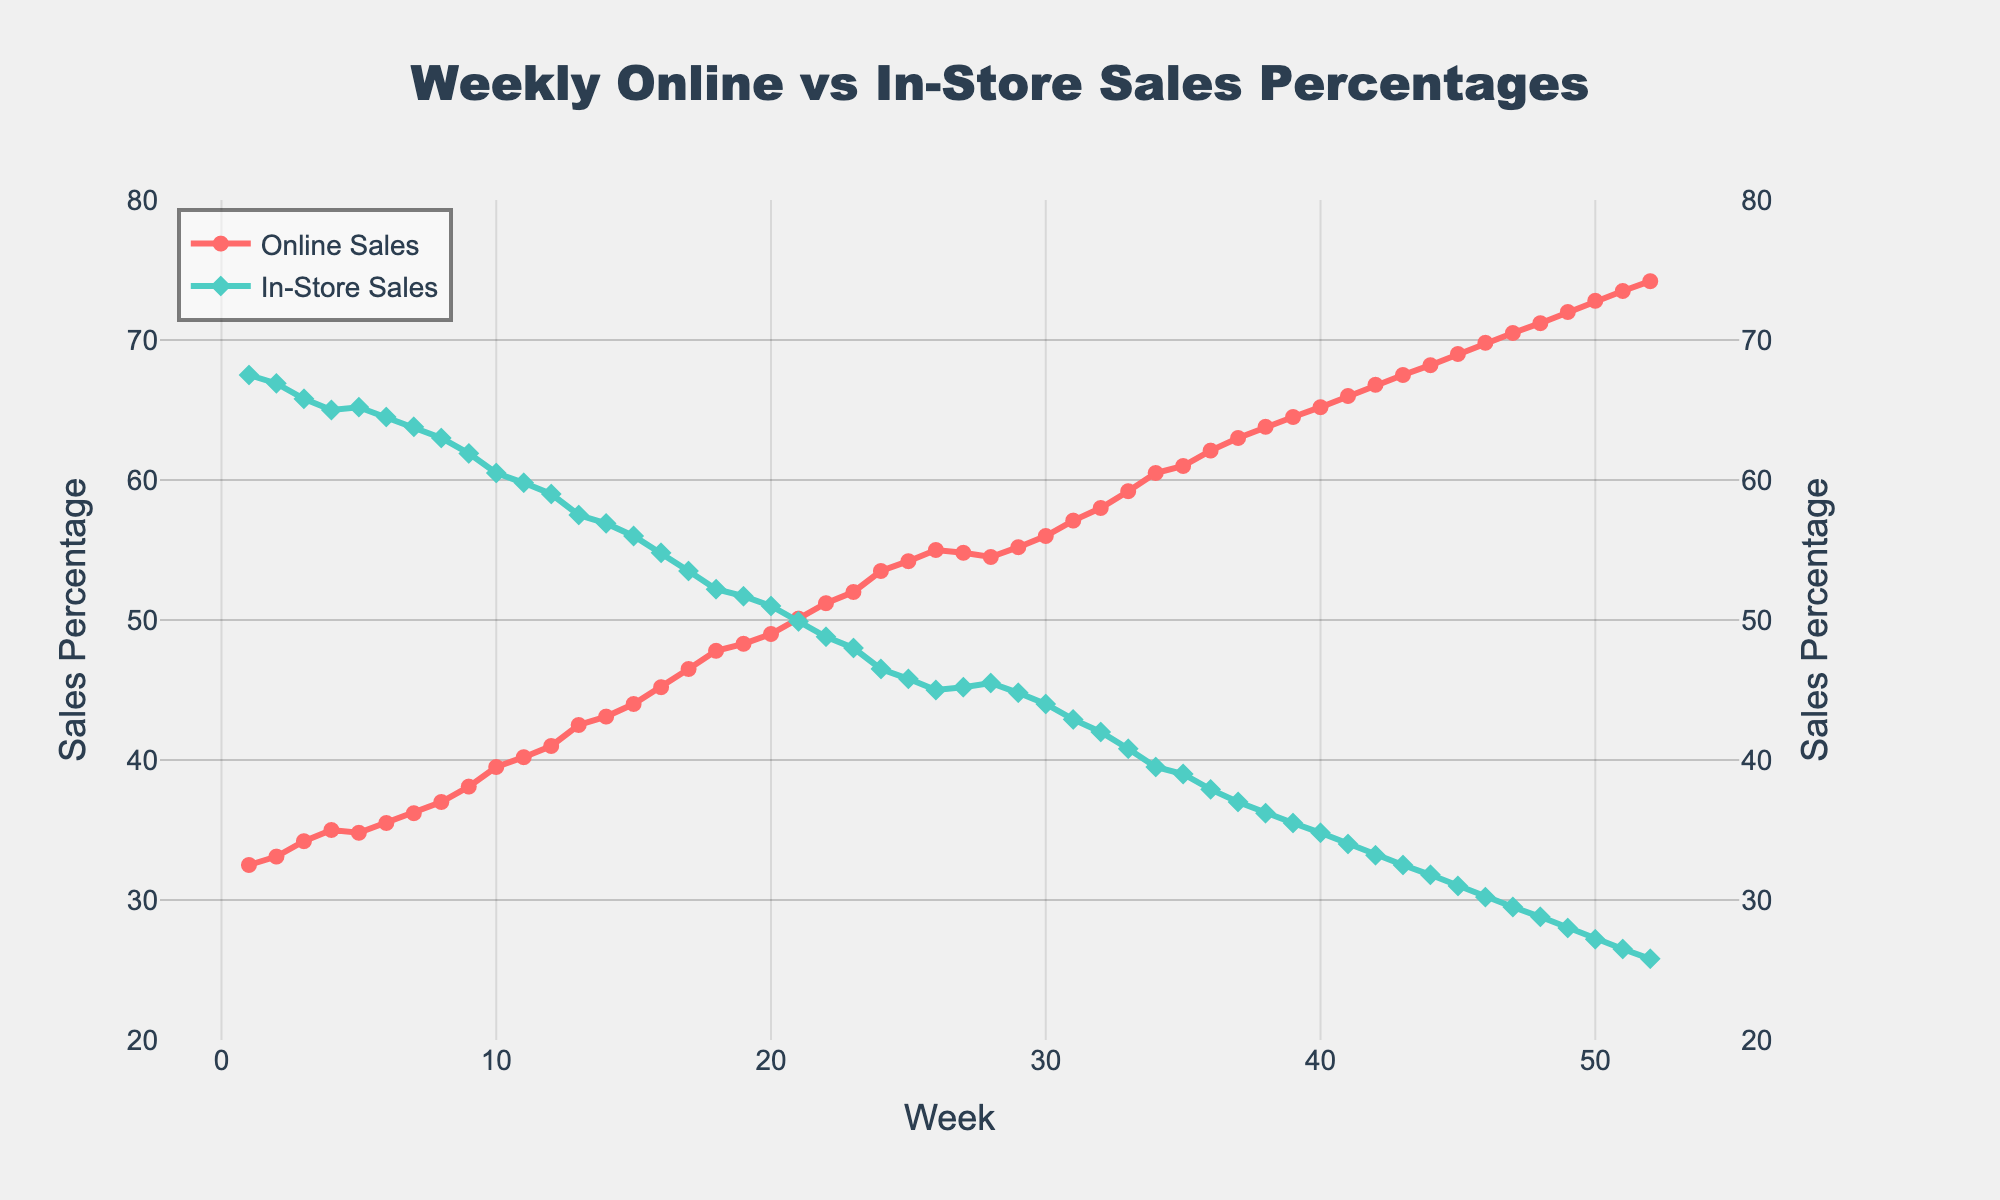What trend can be observed from Week 1 to Week 52 for online sales percentages? Observing the line for online sales percentages, it can be seen that there is a steady increase from Week 1 (32.5%) to Week 52 (74.2%).
Answer: Steady increase In which week do online sales exceed in-store sales for the first time? Online sales exceed in-store sales when the percentage of online sales becomes greater than 50%. This occurs in Week 21, where online sales hit 50.1%.
Answer: Week 21 By how much do online sales increase from Week 1 to Week 25? Online sales start at 32.5% in Week 1 and rise to 54.2% in Week 25. The increase is calculated as 54.2 - 32.5 = 21.7%.
Answer: 21.7% During which week is the gap between online and in-store sales the largest? The gap between online and in-store sales can be observed by subtracting the in-store sales percentage from the online sales percentage. The largest gap occurs in Week 52, with online sales at 74.2% and in-store sales at 25.8%, yielding a gap of 74.2 - 25.8 = 48.4%.
Answer: Week 52 Which week shows the smallest increase in online sales compared to the previous week? Comparing the weekly changes in online sales percentages, the smallest increase is observed from Week 27 to Week 28, where the percentage decreases slightly from 54.8% to 54.5%, showing a -0.3% change.
Answer: Week 28 What is the average in-store sales percentage for the first 10 weeks? Adding the in-store sales percentages from Week 1 to Week 10 (67.5 + 66.9 + 65.8 + 65.0 + 65.2 + 64.5 + 63.8 + 63.0 + 61.9 + 60.5) and dividing by 10 gives the average: (644.1 / 10) = 64.4%.
Answer: 64.4% Overall, are there more weeks when online sales percentages are greater than in-store sales percentages? By examining the data, we note that online sales exceed in-store sales from Week 21 onward. Since there are 52 weeks in total, and starting from Week 21 gives us 32 weeks where online sales are greater, thus, there are more weeks with higher online sales percentages.
Answer: Yes What is the median percentage of online sales for the entire period? Arranging the online sales percentages in ascending order and finding the middle value (or the average of the two middle values for an even number of data points), the median is the average of the 26th and 27th values. Given the values 55.0% and 54.8%, the median is (55.0 + 54.8) / 2 = 54.9%.
Answer: 54.9% Compare the percentage difference between online and in-store sales in Week 1 and Week 52. In Week 1, the difference is 67.5% - 32.5% = 35.0%. In Week 52, the difference is 74.2% - 25.8% = 48.4%. The percentage difference increase from Week 1 to Week 52 is 48.4% - 35.0% = 13.4%.
Answer: 13.4% Explain the visual representation of the online and in-store sales trends over the 52 weeks. The chart shows two distinct lines: one for online sales (red with circle markers) and one for in-store sales (green with diamond markers). Both lines have markers that indicate weekly data points. The red line representing online sales trends upward steadily, crossing over the green line representing in-store sales around Week 21 and continuing to increase until it reaches its peak at Week 52. Conversely, the green line shows a steady decline over time. The crossing of the lines indicates a shift from in-store sales dominance to online sales dominance.
Answer: Online sales increase, in-store sales decrease, online surpasses in-store around Week 21 